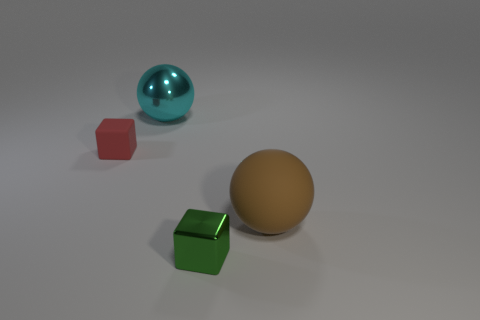Add 4 red shiny cubes. How many objects exist? 8 Subtract 2 blocks. How many blocks are left? 0 Subtract all cyan shiny things. Subtract all brown rubber objects. How many objects are left? 2 Add 2 brown matte spheres. How many brown matte spheres are left? 3 Add 3 tiny gray things. How many tiny gray things exist? 3 Subtract 1 green blocks. How many objects are left? 3 Subtract all blue blocks. Subtract all cyan balls. How many blocks are left? 2 Subtract all blue cubes. How many brown balls are left? 1 